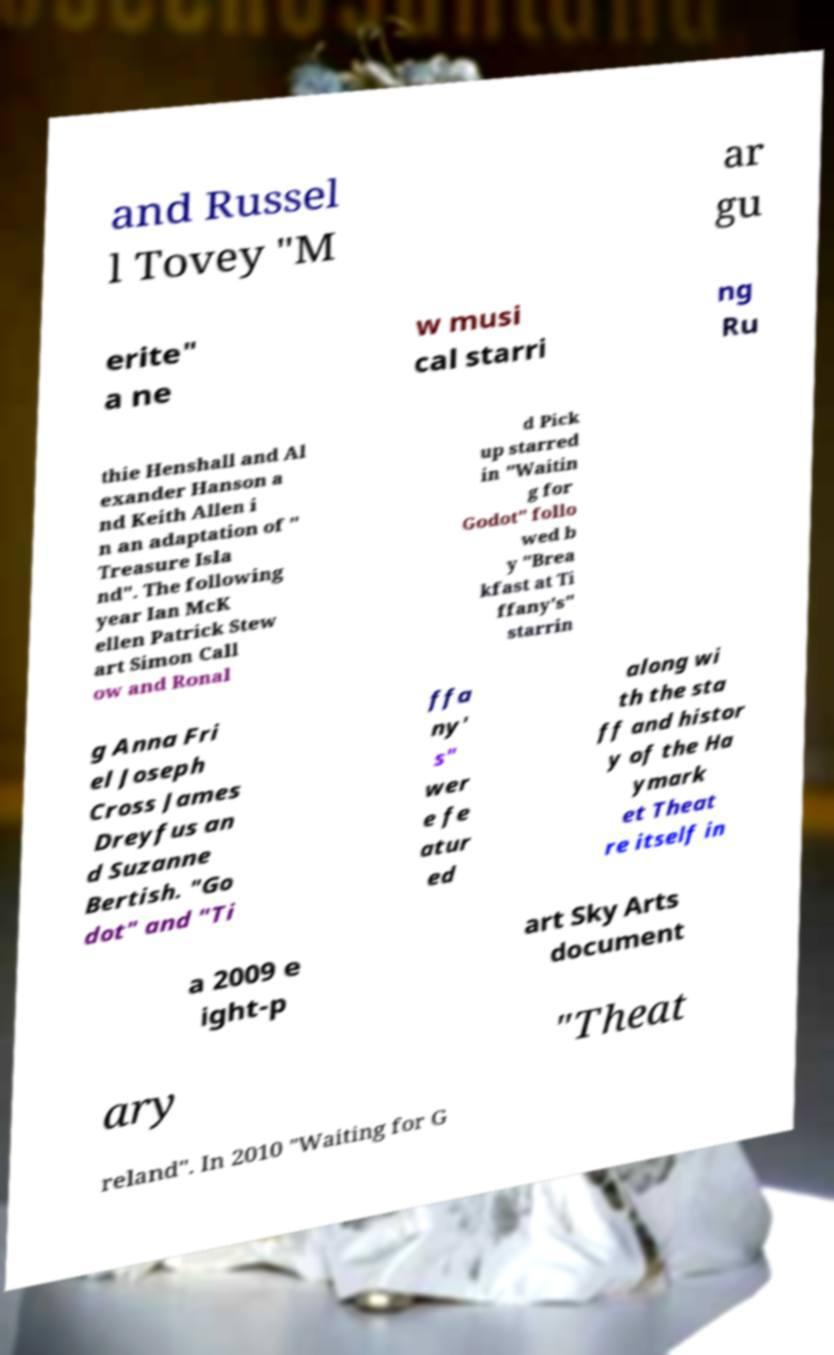I need the written content from this picture converted into text. Can you do that? and Russel l Tovey "M ar gu erite" a ne w musi cal starri ng Ru thie Henshall and Al exander Hanson a nd Keith Allen i n an adaptation of " Treasure Isla nd". The following year Ian McK ellen Patrick Stew art Simon Call ow and Ronal d Pick up starred in "Waitin g for Godot" follo wed b y "Brea kfast at Ti ffany's" starrin g Anna Fri el Joseph Cross James Dreyfus an d Suzanne Bertish. "Go dot" and "Ti ffa ny' s" wer e fe atur ed along wi th the sta ff and histor y of the Ha ymark et Theat re itself in a 2009 e ight-p art Sky Arts document ary "Theat reland". In 2010 "Waiting for G 